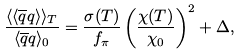<formula> <loc_0><loc_0><loc_500><loc_500>\frac { \langle \langle \overline { q } q \rangle \rangle _ { T } } { \langle \overline { q } q \rangle _ { 0 } } = \frac { \sigma ( T ) } { f _ { \pi } } \left ( \frac { \chi ( T ) } { \chi _ { 0 } } \right ) ^ { 2 } + \Delta ,</formula> 